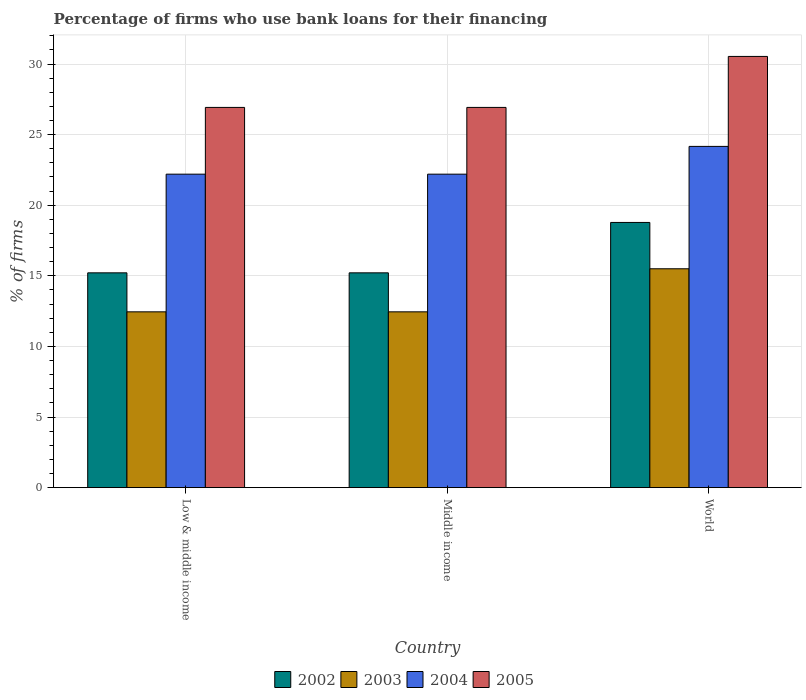How many different coloured bars are there?
Provide a short and direct response. 4. How many groups of bars are there?
Provide a short and direct response. 3. Are the number of bars per tick equal to the number of legend labels?
Your answer should be very brief. Yes. Are the number of bars on each tick of the X-axis equal?
Offer a very short reply. Yes. In how many cases, is the number of bars for a given country not equal to the number of legend labels?
Provide a short and direct response. 0. What is the percentage of firms who use bank loans for their financing in 2003 in Middle income?
Make the answer very short. 12.45. Across all countries, what is the maximum percentage of firms who use bank loans for their financing in 2005?
Your response must be concise. 30.54. Across all countries, what is the minimum percentage of firms who use bank loans for their financing in 2005?
Your answer should be very brief. 26.93. In which country was the percentage of firms who use bank loans for their financing in 2003 maximum?
Give a very brief answer. World. What is the total percentage of firms who use bank loans for their financing in 2002 in the graph?
Your answer should be very brief. 49.21. What is the difference between the percentage of firms who use bank loans for their financing in 2003 in Low & middle income and that in World?
Your answer should be compact. -3.05. What is the difference between the percentage of firms who use bank loans for their financing in 2005 in Low & middle income and the percentage of firms who use bank loans for their financing in 2004 in Middle income?
Offer a terse response. 4.73. What is the average percentage of firms who use bank loans for their financing in 2003 per country?
Ensure brevity in your answer.  13.47. What is the difference between the percentage of firms who use bank loans for their financing of/in 2003 and percentage of firms who use bank loans for their financing of/in 2002 in Low & middle income?
Make the answer very short. -2.76. What is the ratio of the percentage of firms who use bank loans for their financing in 2005 in Low & middle income to that in World?
Provide a short and direct response. 0.88. Is the percentage of firms who use bank loans for their financing in 2005 in Low & middle income less than that in World?
Your response must be concise. Yes. Is the difference between the percentage of firms who use bank loans for their financing in 2003 in Low & middle income and Middle income greater than the difference between the percentage of firms who use bank loans for their financing in 2002 in Low & middle income and Middle income?
Provide a succinct answer. No. What is the difference between the highest and the second highest percentage of firms who use bank loans for their financing in 2005?
Offer a terse response. -3.61. What is the difference between the highest and the lowest percentage of firms who use bank loans for their financing in 2002?
Give a very brief answer. 3.57. In how many countries, is the percentage of firms who use bank loans for their financing in 2005 greater than the average percentage of firms who use bank loans for their financing in 2005 taken over all countries?
Ensure brevity in your answer.  1. Is it the case that in every country, the sum of the percentage of firms who use bank loans for their financing in 2004 and percentage of firms who use bank loans for their financing in 2002 is greater than the sum of percentage of firms who use bank loans for their financing in 2003 and percentage of firms who use bank loans for their financing in 2005?
Provide a short and direct response. Yes. How many bars are there?
Keep it short and to the point. 12. How many countries are there in the graph?
Your answer should be very brief. 3. Are the values on the major ticks of Y-axis written in scientific E-notation?
Keep it short and to the point. No. Does the graph contain any zero values?
Ensure brevity in your answer.  No. Where does the legend appear in the graph?
Offer a very short reply. Bottom center. How are the legend labels stacked?
Provide a succinct answer. Horizontal. What is the title of the graph?
Offer a terse response. Percentage of firms who use bank loans for their financing. What is the label or title of the Y-axis?
Make the answer very short. % of firms. What is the % of firms in 2002 in Low & middle income?
Your answer should be compact. 15.21. What is the % of firms of 2003 in Low & middle income?
Your answer should be compact. 12.45. What is the % of firms in 2004 in Low & middle income?
Offer a terse response. 22.2. What is the % of firms of 2005 in Low & middle income?
Give a very brief answer. 26.93. What is the % of firms in 2002 in Middle income?
Provide a short and direct response. 15.21. What is the % of firms of 2003 in Middle income?
Make the answer very short. 12.45. What is the % of firms of 2004 in Middle income?
Keep it short and to the point. 22.2. What is the % of firms in 2005 in Middle income?
Offer a very short reply. 26.93. What is the % of firms of 2002 in World?
Provide a succinct answer. 18.78. What is the % of firms of 2004 in World?
Your response must be concise. 24.17. What is the % of firms in 2005 in World?
Make the answer very short. 30.54. Across all countries, what is the maximum % of firms of 2002?
Give a very brief answer. 18.78. Across all countries, what is the maximum % of firms in 2003?
Offer a very short reply. 15.5. Across all countries, what is the maximum % of firms in 2004?
Provide a succinct answer. 24.17. Across all countries, what is the maximum % of firms in 2005?
Your answer should be compact. 30.54. Across all countries, what is the minimum % of firms of 2002?
Provide a short and direct response. 15.21. Across all countries, what is the minimum % of firms in 2003?
Ensure brevity in your answer.  12.45. Across all countries, what is the minimum % of firms of 2005?
Ensure brevity in your answer.  26.93. What is the total % of firms of 2002 in the graph?
Provide a succinct answer. 49.21. What is the total % of firms of 2003 in the graph?
Provide a short and direct response. 40.4. What is the total % of firms of 2004 in the graph?
Offer a terse response. 68.57. What is the total % of firms of 2005 in the graph?
Keep it short and to the point. 84.39. What is the difference between the % of firms in 2002 in Low & middle income and that in Middle income?
Offer a terse response. 0. What is the difference between the % of firms in 2005 in Low & middle income and that in Middle income?
Keep it short and to the point. 0. What is the difference between the % of firms of 2002 in Low & middle income and that in World?
Offer a terse response. -3.57. What is the difference between the % of firms in 2003 in Low & middle income and that in World?
Offer a terse response. -3.05. What is the difference between the % of firms of 2004 in Low & middle income and that in World?
Provide a succinct answer. -1.97. What is the difference between the % of firms in 2005 in Low & middle income and that in World?
Offer a very short reply. -3.61. What is the difference between the % of firms of 2002 in Middle income and that in World?
Keep it short and to the point. -3.57. What is the difference between the % of firms in 2003 in Middle income and that in World?
Your answer should be compact. -3.05. What is the difference between the % of firms in 2004 in Middle income and that in World?
Provide a succinct answer. -1.97. What is the difference between the % of firms of 2005 in Middle income and that in World?
Keep it short and to the point. -3.61. What is the difference between the % of firms in 2002 in Low & middle income and the % of firms in 2003 in Middle income?
Ensure brevity in your answer.  2.76. What is the difference between the % of firms in 2002 in Low & middle income and the % of firms in 2004 in Middle income?
Provide a succinct answer. -6.99. What is the difference between the % of firms in 2002 in Low & middle income and the % of firms in 2005 in Middle income?
Offer a terse response. -11.72. What is the difference between the % of firms of 2003 in Low & middle income and the % of firms of 2004 in Middle income?
Provide a succinct answer. -9.75. What is the difference between the % of firms of 2003 in Low & middle income and the % of firms of 2005 in Middle income?
Keep it short and to the point. -14.48. What is the difference between the % of firms in 2004 in Low & middle income and the % of firms in 2005 in Middle income?
Keep it short and to the point. -4.73. What is the difference between the % of firms in 2002 in Low & middle income and the % of firms in 2003 in World?
Provide a short and direct response. -0.29. What is the difference between the % of firms in 2002 in Low & middle income and the % of firms in 2004 in World?
Your answer should be very brief. -8.95. What is the difference between the % of firms of 2002 in Low & middle income and the % of firms of 2005 in World?
Offer a terse response. -15.33. What is the difference between the % of firms in 2003 in Low & middle income and the % of firms in 2004 in World?
Your answer should be compact. -11.72. What is the difference between the % of firms in 2003 in Low & middle income and the % of firms in 2005 in World?
Your answer should be very brief. -18.09. What is the difference between the % of firms of 2004 in Low & middle income and the % of firms of 2005 in World?
Offer a terse response. -8.34. What is the difference between the % of firms of 2002 in Middle income and the % of firms of 2003 in World?
Provide a succinct answer. -0.29. What is the difference between the % of firms of 2002 in Middle income and the % of firms of 2004 in World?
Provide a succinct answer. -8.95. What is the difference between the % of firms of 2002 in Middle income and the % of firms of 2005 in World?
Offer a terse response. -15.33. What is the difference between the % of firms of 2003 in Middle income and the % of firms of 2004 in World?
Provide a short and direct response. -11.72. What is the difference between the % of firms in 2003 in Middle income and the % of firms in 2005 in World?
Provide a succinct answer. -18.09. What is the difference between the % of firms in 2004 in Middle income and the % of firms in 2005 in World?
Your answer should be very brief. -8.34. What is the average % of firms in 2002 per country?
Your response must be concise. 16.4. What is the average % of firms in 2003 per country?
Your answer should be compact. 13.47. What is the average % of firms of 2004 per country?
Ensure brevity in your answer.  22.86. What is the average % of firms of 2005 per country?
Offer a very short reply. 28.13. What is the difference between the % of firms of 2002 and % of firms of 2003 in Low & middle income?
Offer a terse response. 2.76. What is the difference between the % of firms in 2002 and % of firms in 2004 in Low & middle income?
Make the answer very short. -6.99. What is the difference between the % of firms in 2002 and % of firms in 2005 in Low & middle income?
Give a very brief answer. -11.72. What is the difference between the % of firms in 2003 and % of firms in 2004 in Low & middle income?
Make the answer very short. -9.75. What is the difference between the % of firms of 2003 and % of firms of 2005 in Low & middle income?
Give a very brief answer. -14.48. What is the difference between the % of firms of 2004 and % of firms of 2005 in Low & middle income?
Your answer should be very brief. -4.73. What is the difference between the % of firms in 2002 and % of firms in 2003 in Middle income?
Your response must be concise. 2.76. What is the difference between the % of firms in 2002 and % of firms in 2004 in Middle income?
Your answer should be compact. -6.99. What is the difference between the % of firms in 2002 and % of firms in 2005 in Middle income?
Offer a very short reply. -11.72. What is the difference between the % of firms of 2003 and % of firms of 2004 in Middle income?
Your answer should be very brief. -9.75. What is the difference between the % of firms in 2003 and % of firms in 2005 in Middle income?
Give a very brief answer. -14.48. What is the difference between the % of firms of 2004 and % of firms of 2005 in Middle income?
Give a very brief answer. -4.73. What is the difference between the % of firms of 2002 and % of firms of 2003 in World?
Ensure brevity in your answer.  3.28. What is the difference between the % of firms in 2002 and % of firms in 2004 in World?
Ensure brevity in your answer.  -5.39. What is the difference between the % of firms of 2002 and % of firms of 2005 in World?
Your answer should be very brief. -11.76. What is the difference between the % of firms of 2003 and % of firms of 2004 in World?
Your answer should be very brief. -8.67. What is the difference between the % of firms in 2003 and % of firms in 2005 in World?
Keep it short and to the point. -15.04. What is the difference between the % of firms in 2004 and % of firms in 2005 in World?
Your answer should be compact. -6.37. What is the ratio of the % of firms of 2005 in Low & middle income to that in Middle income?
Keep it short and to the point. 1. What is the ratio of the % of firms in 2002 in Low & middle income to that in World?
Make the answer very short. 0.81. What is the ratio of the % of firms of 2003 in Low & middle income to that in World?
Ensure brevity in your answer.  0.8. What is the ratio of the % of firms of 2004 in Low & middle income to that in World?
Ensure brevity in your answer.  0.92. What is the ratio of the % of firms in 2005 in Low & middle income to that in World?
Offer a very short reply. 0.88. What is the ratio of the % of firms of 2002 in Middle income to that in World?
Provide a succinct answer. 0.81. What is the ratio of the % of firms in 2003 in Middle income to that in World?
Ensure brevity in your answer.  0.8. What is the ratio of the % of firms of 2004 in Middle income to that in World?
Your answer should be compact. 0.92. What is the ratio of the % of firms of 2005 in Middle income to that in World?
Make the answer very short. 0.88. What is the difference between the highest and the second highest % of firms of 2002?
Your response must be concise. 3.57. What is the difference between the highest and the second highest % of firms in 2003?
Provide a succinct answer. 3.05. What is the difference between the highest and the second highest % of firms of 2004?
Make the answer very short. 1.97. What is the difference between the highest and the second highest % of firms of 2005?
Provide a short and direct response. 3.61. What is the difference between the highest and the lowest % of firms in 2002?
Keep it short and to the point. 3.57. What is the difference between the highest and the lowest % of firms in 2003?
Offer a very short reply. 3.05. What is the difference between the highest and the lowest % of firms of 2004?
Provide a succinct answer. 1.97. What is the difference between the highest and the lowest % of firms in 2005?
Give a very brief answer. 3.61. 